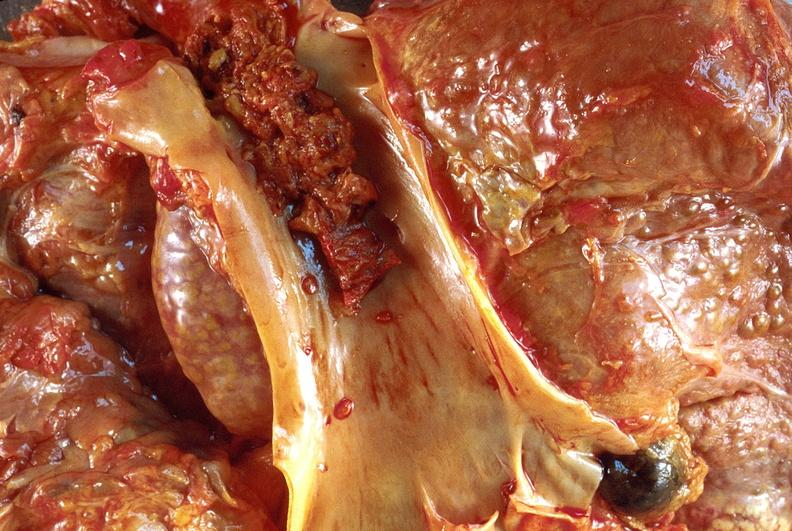does choanal atresia show hepatocellular carcinoma, hepatitis c positive?
Answer the question using a single word or phrase. No 